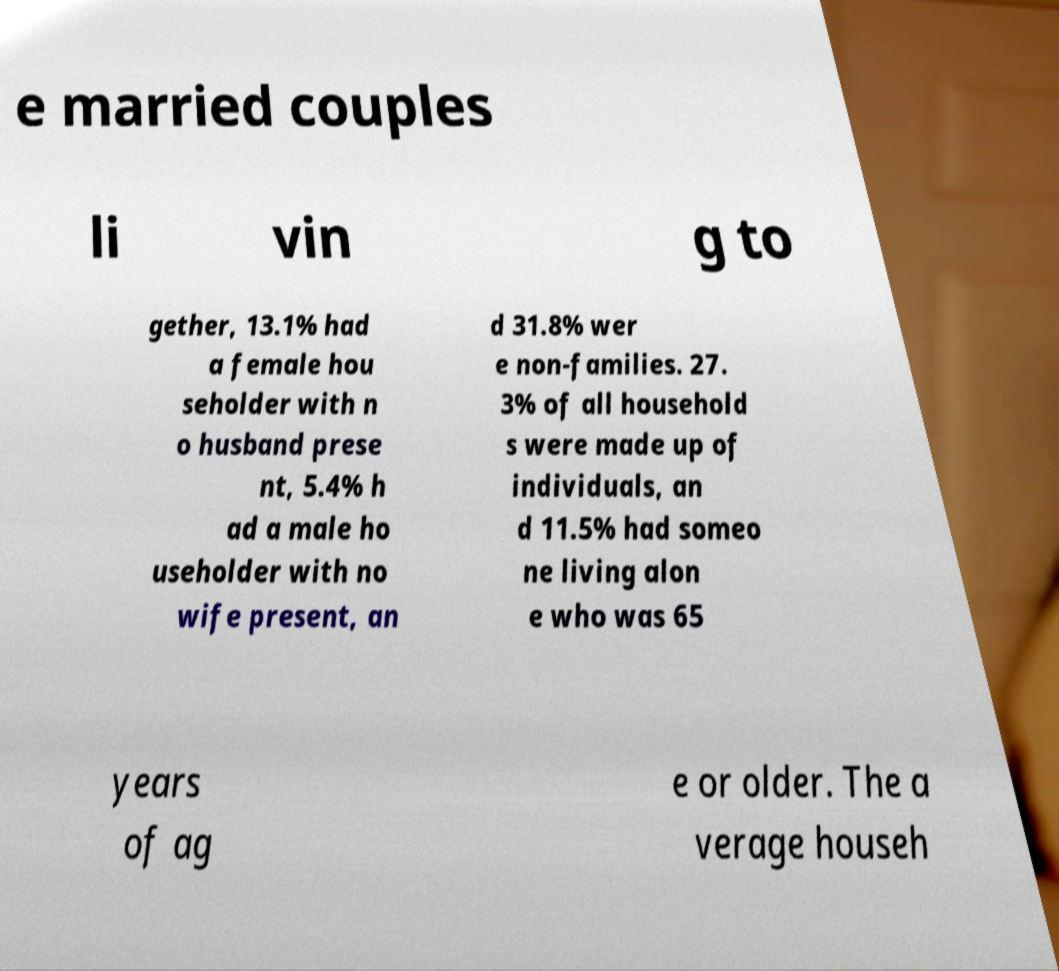Please read and relay the text visible in this image. What does it say? e married couples li vin g to gether, 13.1% had a female hou seholder with n o husband prese nt, 5.4% h ad a male ho useholder with no wife present, an d 31.8% wer e non-families. 27. 3% of all household s were made up of individuals, an d 11.5% had someo ne living alon e who was 65 years of ag e or older. The a verage househ 